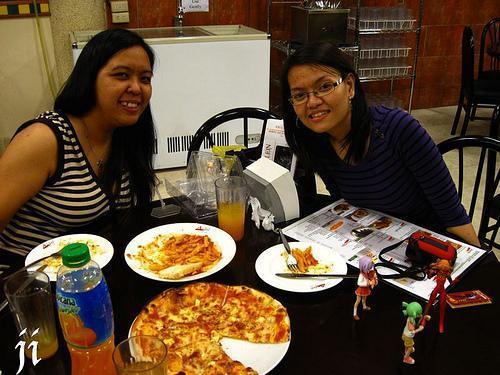How many plates are in this image?
Give a very brief answer. 4. How many pizzas are pictured?
Give a very brief answer. 1. How many chairs are there?
Give a very brief answer. 3. How many people are visible?
Give a very brief answer. 2. How many pizzas are in the picture?
Give a very brief answer. 2. 